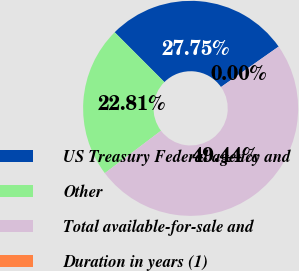Convert chart. <chart><loc_0><loc_0><loc_500><loc_500><pie_chart><fcel>US Treasury Federal agency and<fcel>Other<fcel>Total available-for-sale and<fcel>Duration in years (1)<nl><fcel>27.75%<fcel>22.81%<fcel>49.44%<fcel>0.0%<nl></chart> 